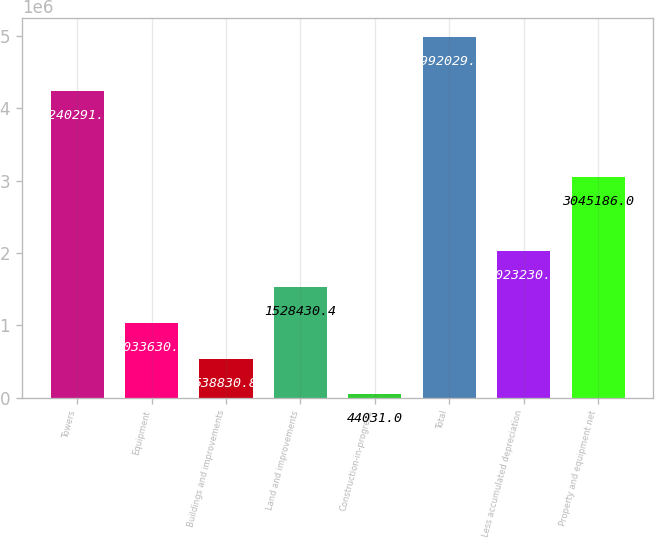<chart> <loc_0><loc_0><loc_500><loc_500><bar_chart><fcel>Towers<fcel>Equipment<fcel>Buildings and improvements<fcel>Land and improvements<fcel>Construction-in-progress<fcel>Total<fcel>Less accumulated depreciation<fcel>Property and equipment net<nl><fcel>4.24029e+06<fcel>1.03363e+06<fcel>538831<fcel>1.52843e+06<fcel>44031<fcel>4.99203e+06<fcel>2.02323e+06<fcel>3.04519e+06<nl></chart> 